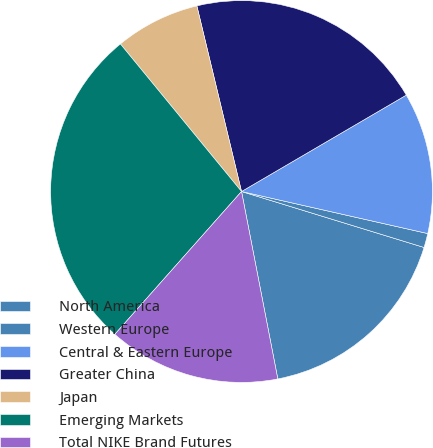Convert chart to OTSL. <chart><loc_0><loc_0><loc_500><loc_500><pie_chart><fcel>North America<fcel>Western Europe<fcel>Central & Eastern Europe<fcel>Greater China<fcel>Japan<fcel>Emerging Markets<fcel>Total NIKE Brand Futures<nl><fcel>17.22%<fcel>1.2%<fcel>11.96%<fcel>20.33%<fcel>7.18%<fcel>27.51%<fcel>14.59%<nl></chart> 